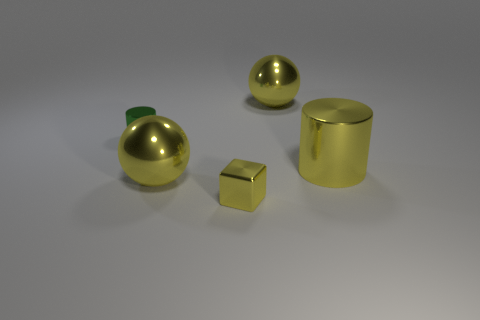There is a shiny sphere that is in front of the small green cylinder; is there a tiny cylinder that is in front of it?
Give a very brief answer. No. What number of objects are metal spheres behind the green thing or tiny blue matte cylinders?
Ensure brevity in your answer.  1. How many big green metallic balls are there?
Offer a terse response. 0. What shape is the small thing that is made of the same material as the green cylinder?
Your response must be concise. Cube. There is a metal sphere that is right of the small shiny object that is in front of the big shiny cylinder; how big is it?
Make the answer very short. Large. What number of objects are either yellow metallic spheres that are to the right of the block or large balls behind the big yellow cylinder?
Your answer should be compact. 1. Are there fewer tiny yellow metallic things than tiny brown metallic spheres?
Provide a short and direct response. No. How many objects are either brown blocks or big cylinders?
Offer a terse response. 1. Is the shape of the green thing the same as the small yellow metallic thing?
Ensure brevity in your answer.  No. Are there any other things that have the same material as the small cylinder?
Give a very brief answer. Yes. 